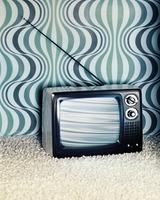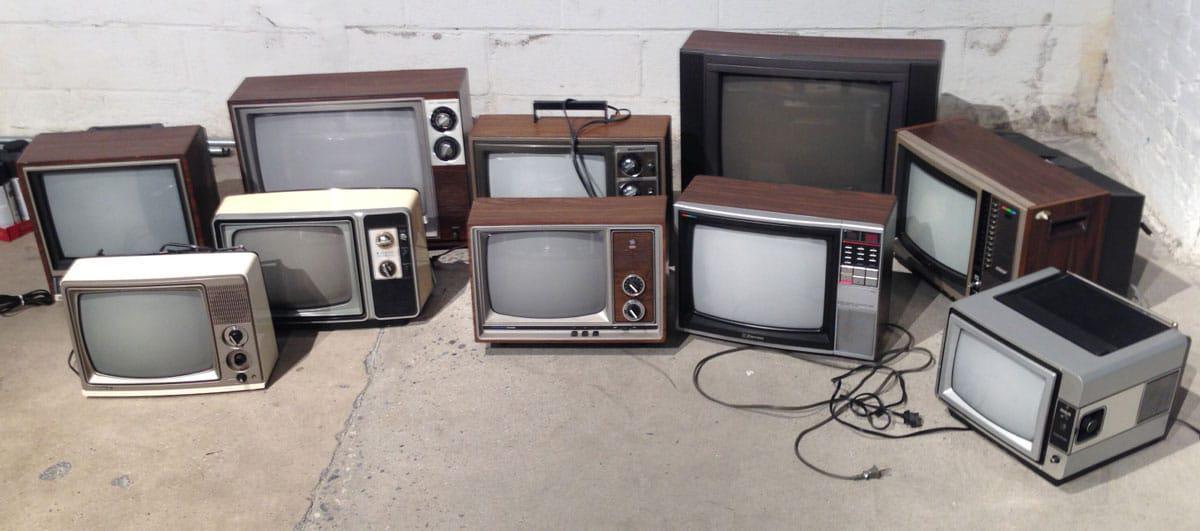The first image is the image on the left, the second image is the image on the right. For the images displayed, is the sentence "One image includes only a single television set." factually correct? Answer yes or no. Yes. The first image is the image on the left, the second image is the image on the right. Given the left and right images, does the statement "An image includes a vertical stack of four TVs, stacked from the biggest on the bottom to the smallest on top." hold true? Answer yes or no. No. 